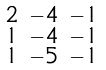Convert formula to latex. <formula><loc_0><loc_0><loc_500><loc_500>\begin{smallmatrix} 2 & - 4 & - 1 \\ 1 & - 4 & - 1 \\ 1 & - 5 & - 1 \end{smallmatrix}</formula> 